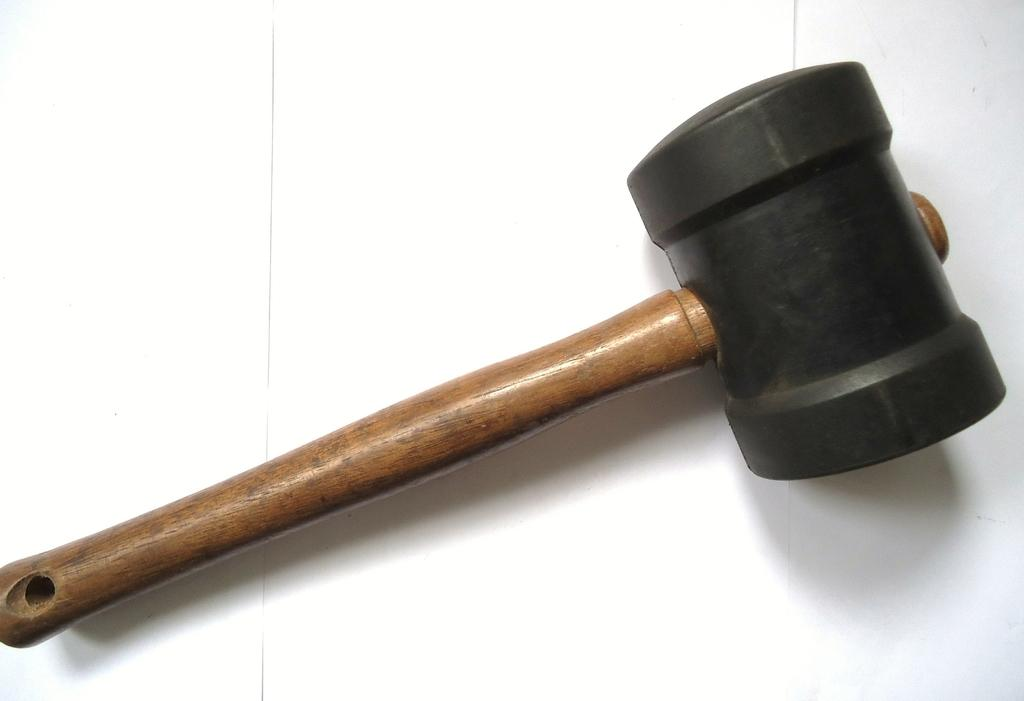What type of tool is present in the image? There is a rubber hammer in the image. What other object can be seen in the image? There is a wooden stick in the image. What type of church is depicted in the image? There is no church present in the image; it only features a rubber hammer and a wooden stick. How does the wrist appear in the image? There is no wrist visible in the image. 